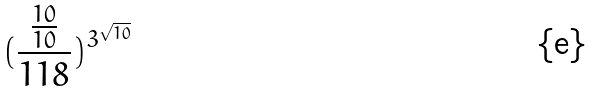<formula> <loc_0><loc_0><loc_500><loc_500>( \frac { \frac { 1 0 } { 1 0 } } { 1 1 8 } ) ^ { 3 ^ { \sqrt { 1 0 } } }</formula> 